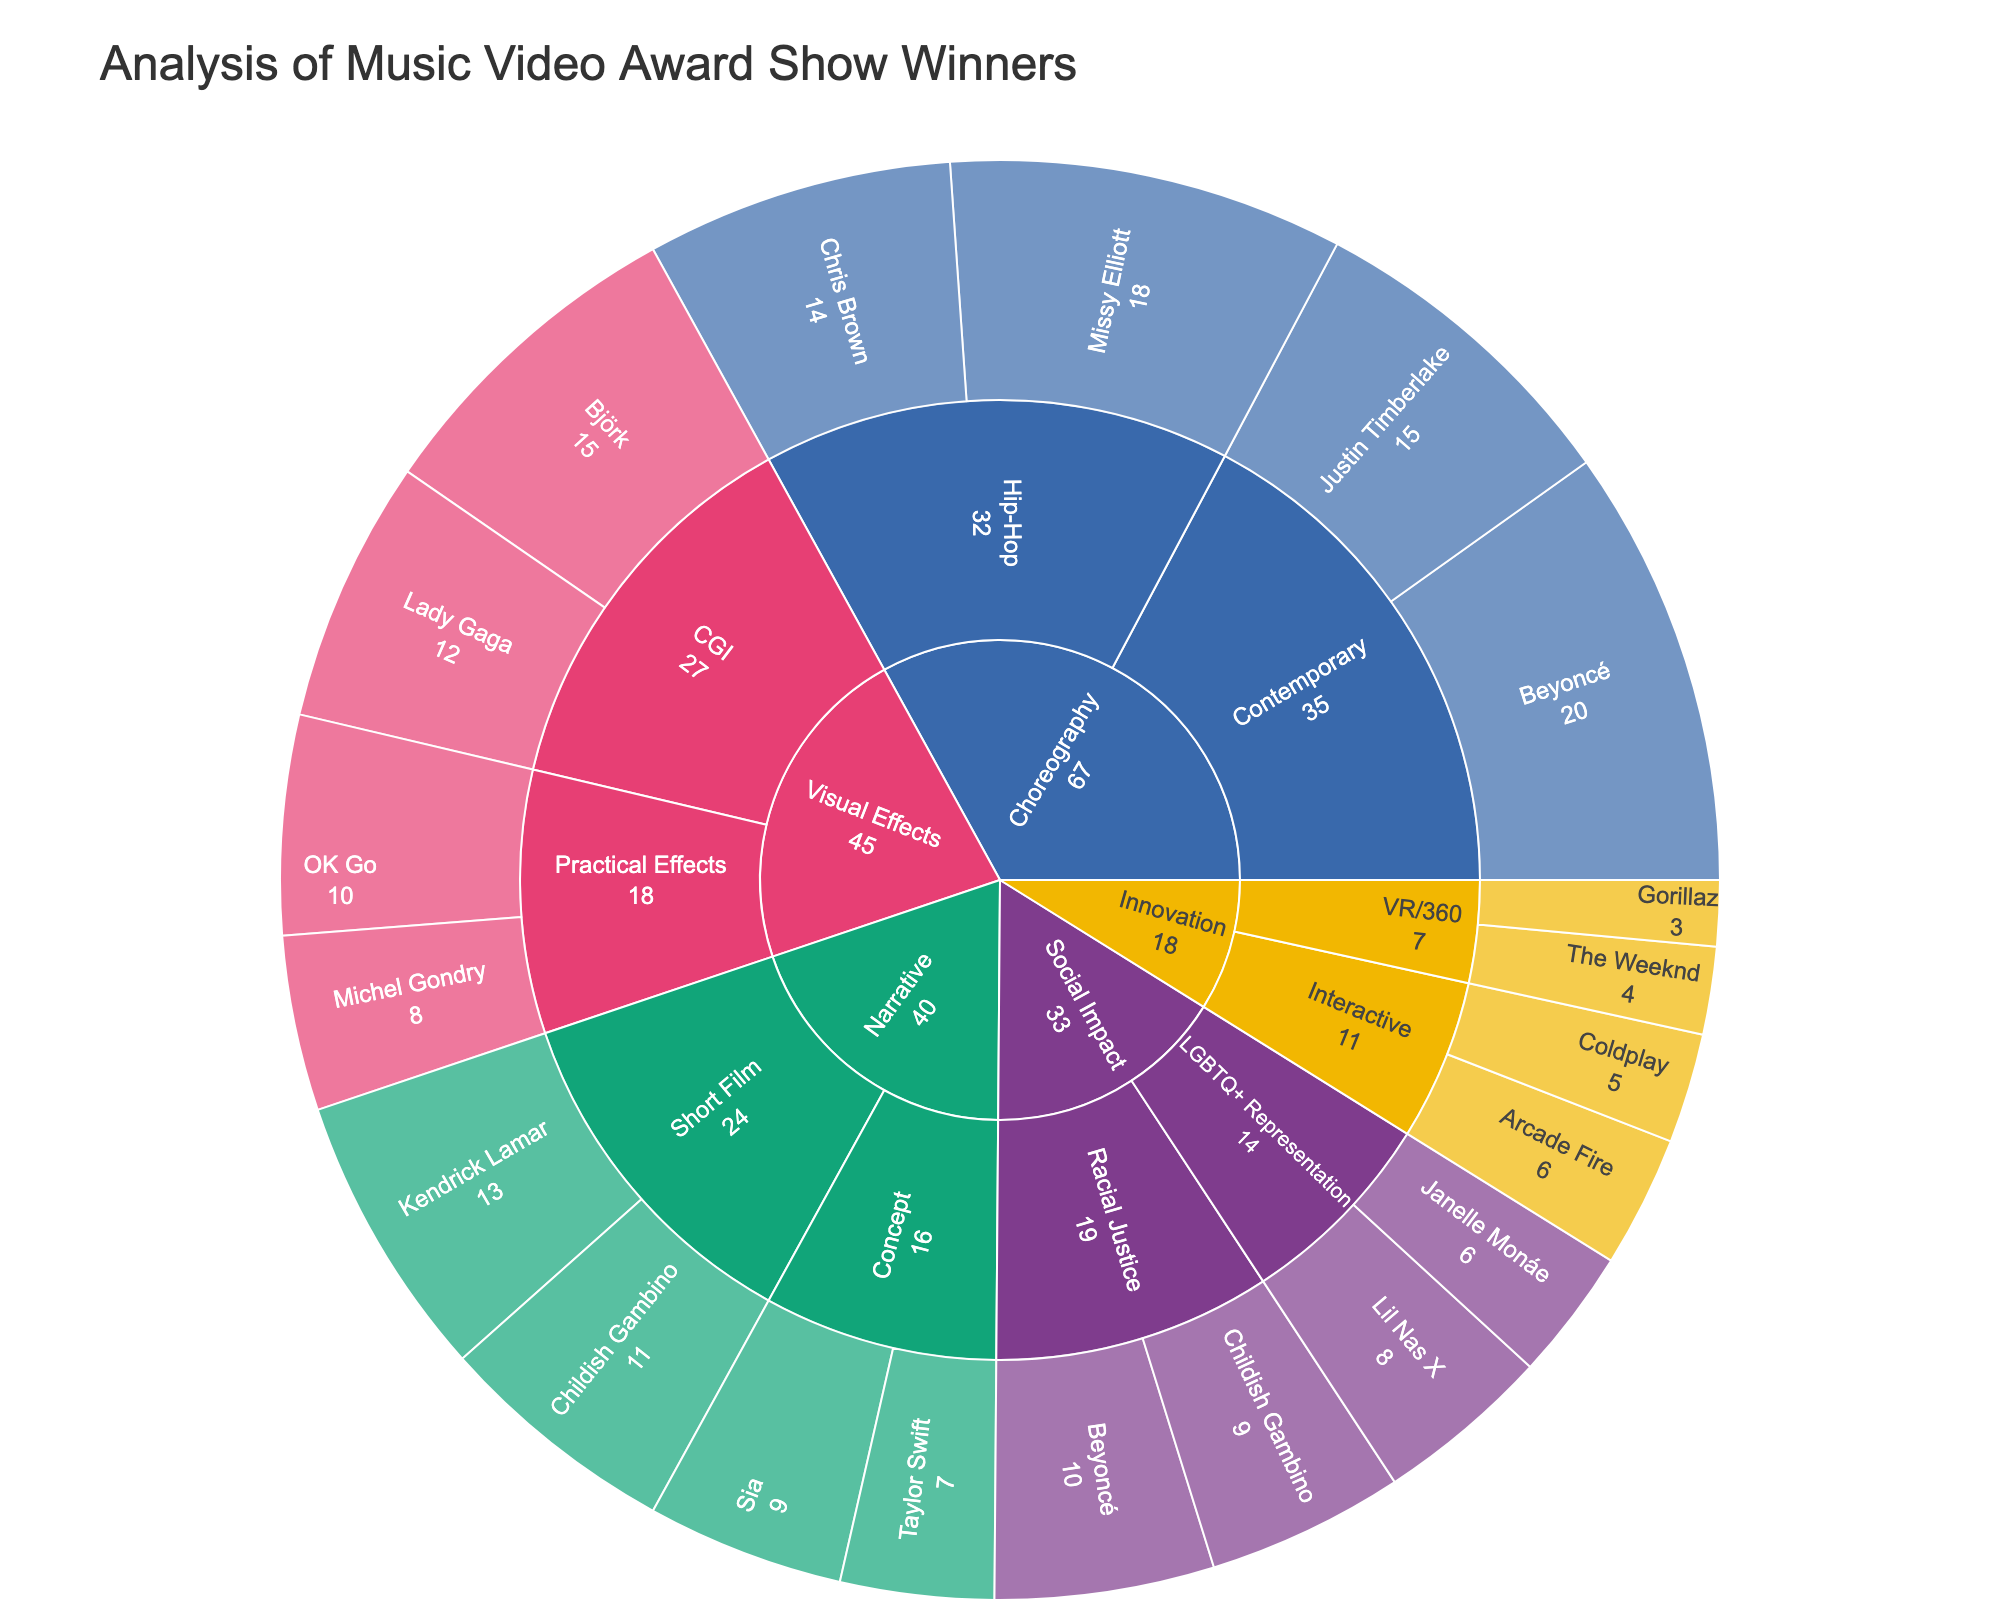What is the title of the Sunburst Plot? The title of the plot is prominently displayed at the top of the figure and is typically one of the easiest elements to identify.
Answer: Analysis of Music Video Award Show Winners Which category has the highest total value of awards? In a Sunburst Plot, the total value for each category can be visually measured by the size of the segment representing that category. By examining the plot, the category with the largest segment can be discerned.
Answer: Choreography Which artist has the highest award value in the Visual Effects category? By navigating through the paths in the Sunburst Plot to the Visual Effects category and then to each artist within it, we can compare their values.
Answer: Björk What is the combined value of awards for artists in the Hip-Hop subcategory of Choreography? Add the values associated with each artist under the Hip-Hop subcategory in the Choreography category. The values given are 18 (Missy Elliott) and 14 (Chris Brown).
Answer: 32 Between the Subcategories "Interactive" and "VR/360" within the Innovation category, which one has a higher total value? Sum the values of the artists within each subcategory and compare the totals. Interactive has values 6 (Arcade Fire) and 5 (Coldplay); VR/360 has values 4 (The Weeknd) and 3 (Gorillaz).
Answer: Interactive Which category has the smallest representation in the plot? Visually identify the category with the smallest segment on the outer ring of the Sunburst Plot.
Answer: Innovation How many artists have won awards in the Narrative category? Count the total number of unique artist segments within the narrative section of the Sunburst Plot.
Answer: 4 Which artist appears in both the Social Impact and Narrative categories? By examining the paths in both the Social Impact and Narrative categories, identify if any artist name is present in both groups.
Answer: Childish Gambino What is the difference between the total values of the Contemporary and CGI subcategories? Calculate the total value for the Contemporary (20 + 15 = 35) and CGI (15 + 12 = 27) subcategories, then subtract the latter from the former.
Answer: 8 